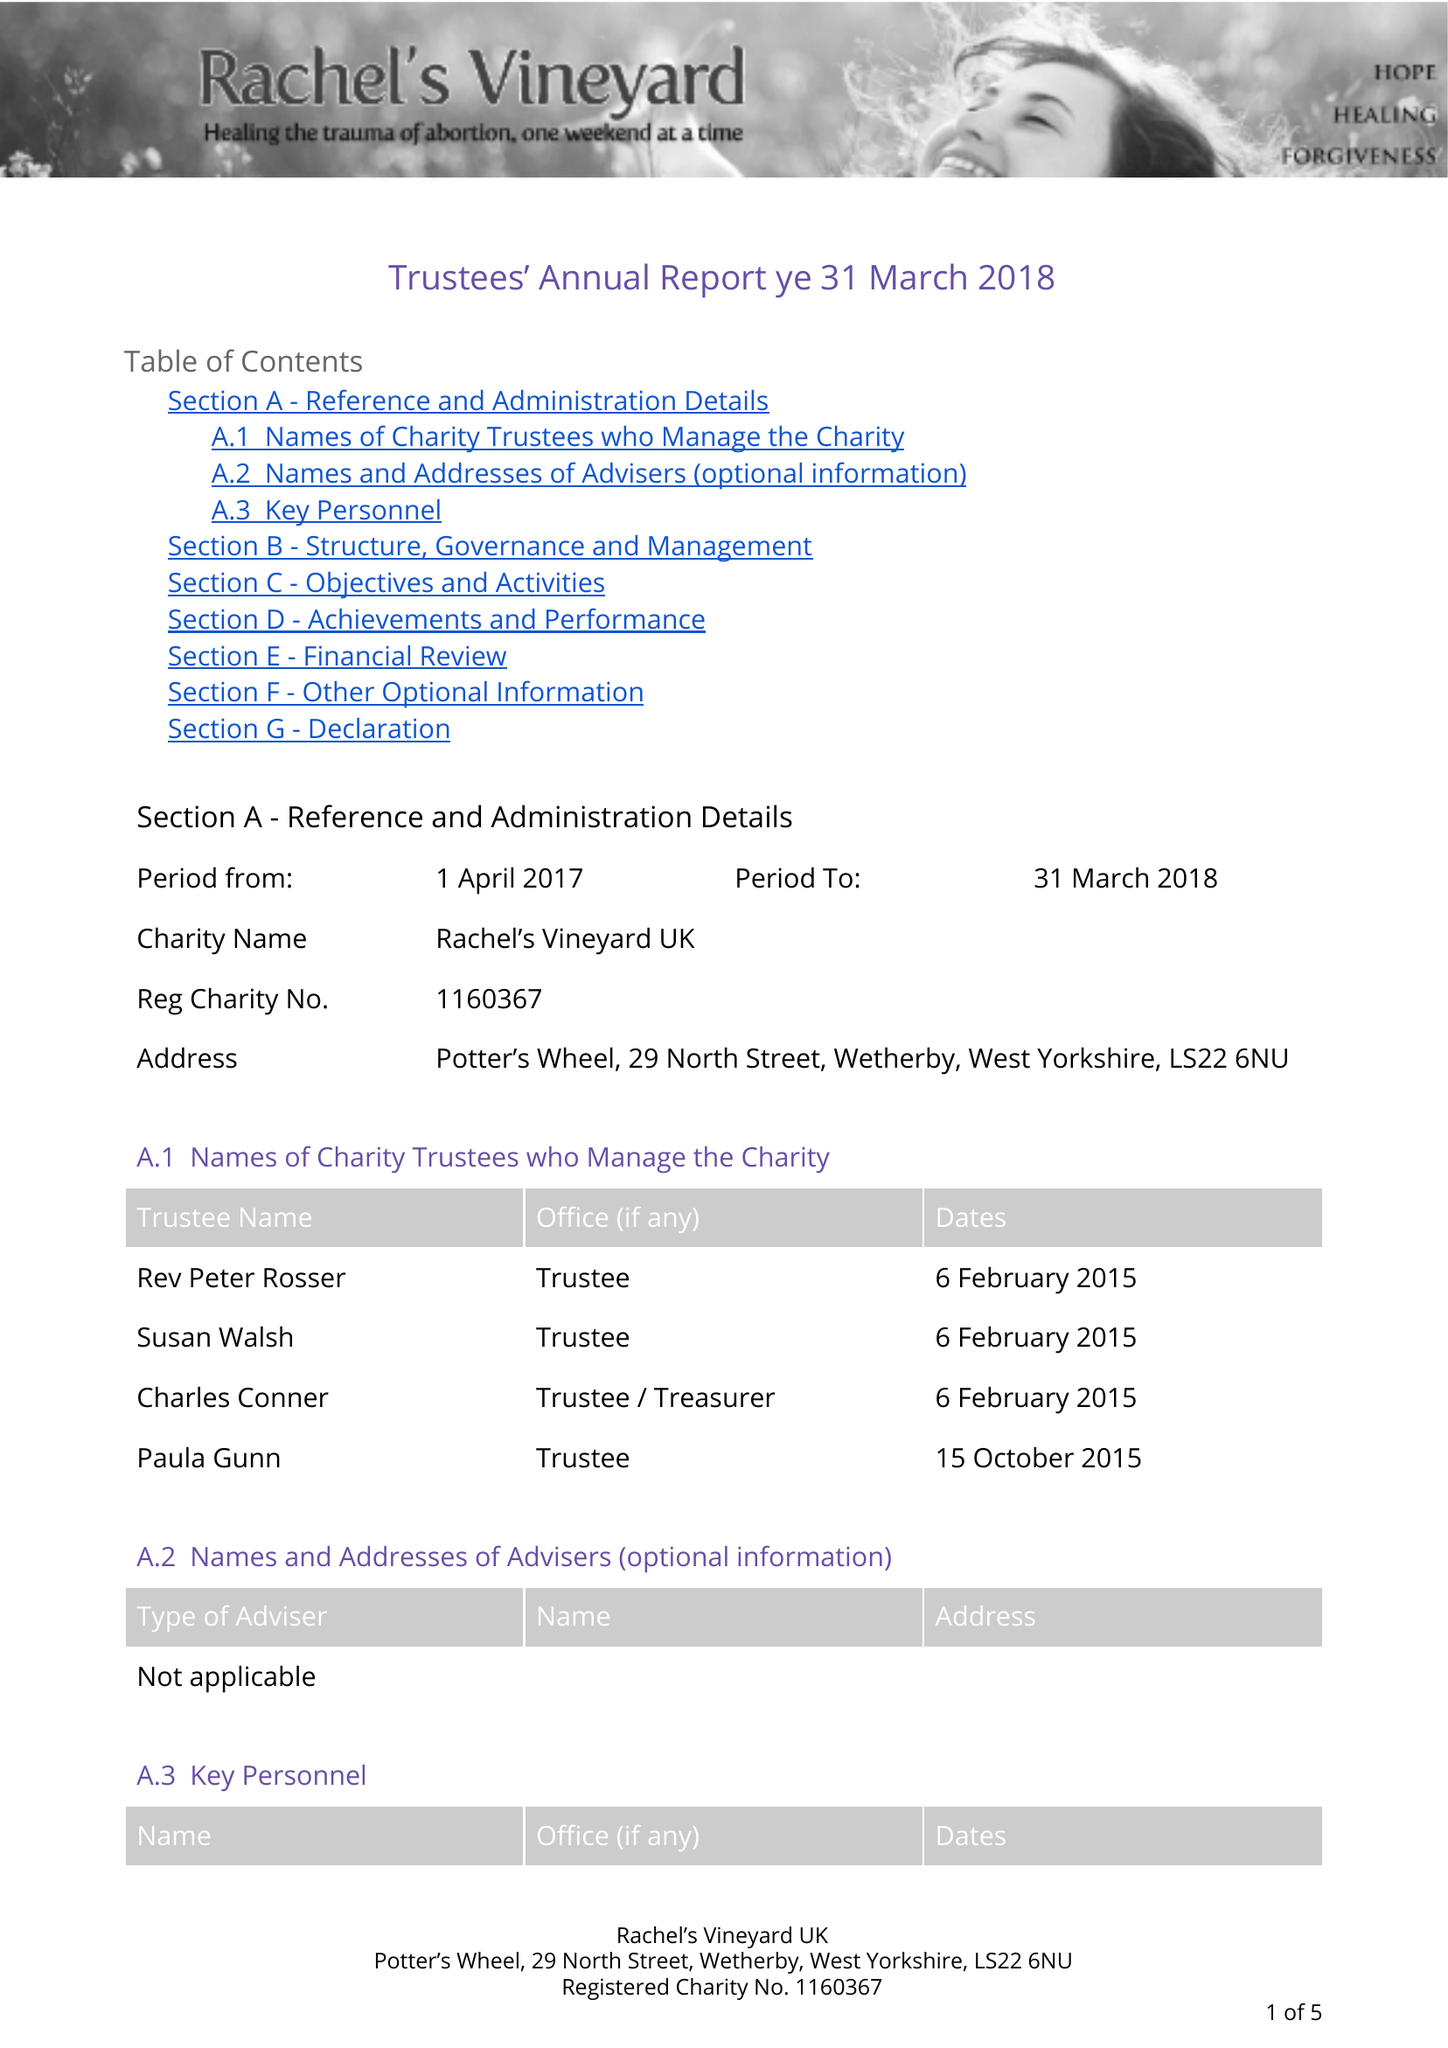What is the value for the address__post_town?
Answer the question using a single word or phrase. WETHERBY 